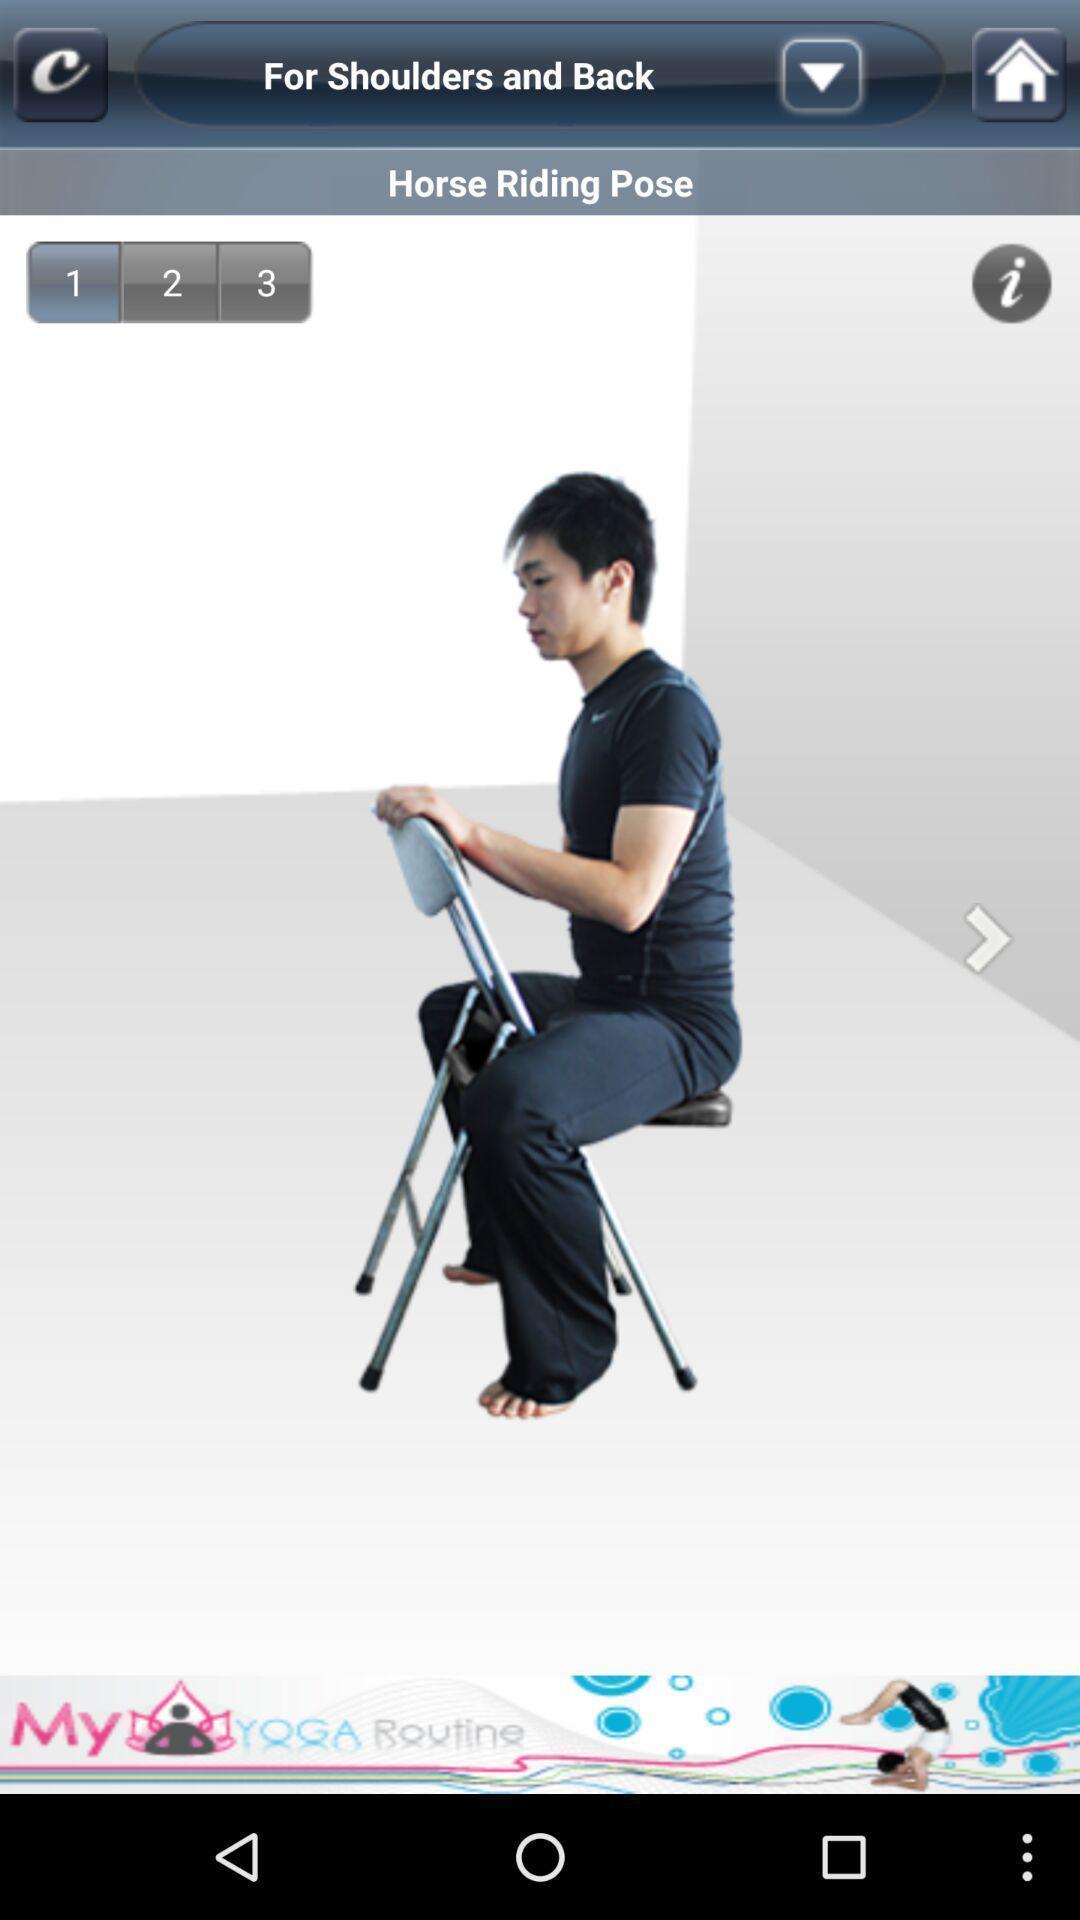What is the overall content of this screenshot? Screen showing a pose. 